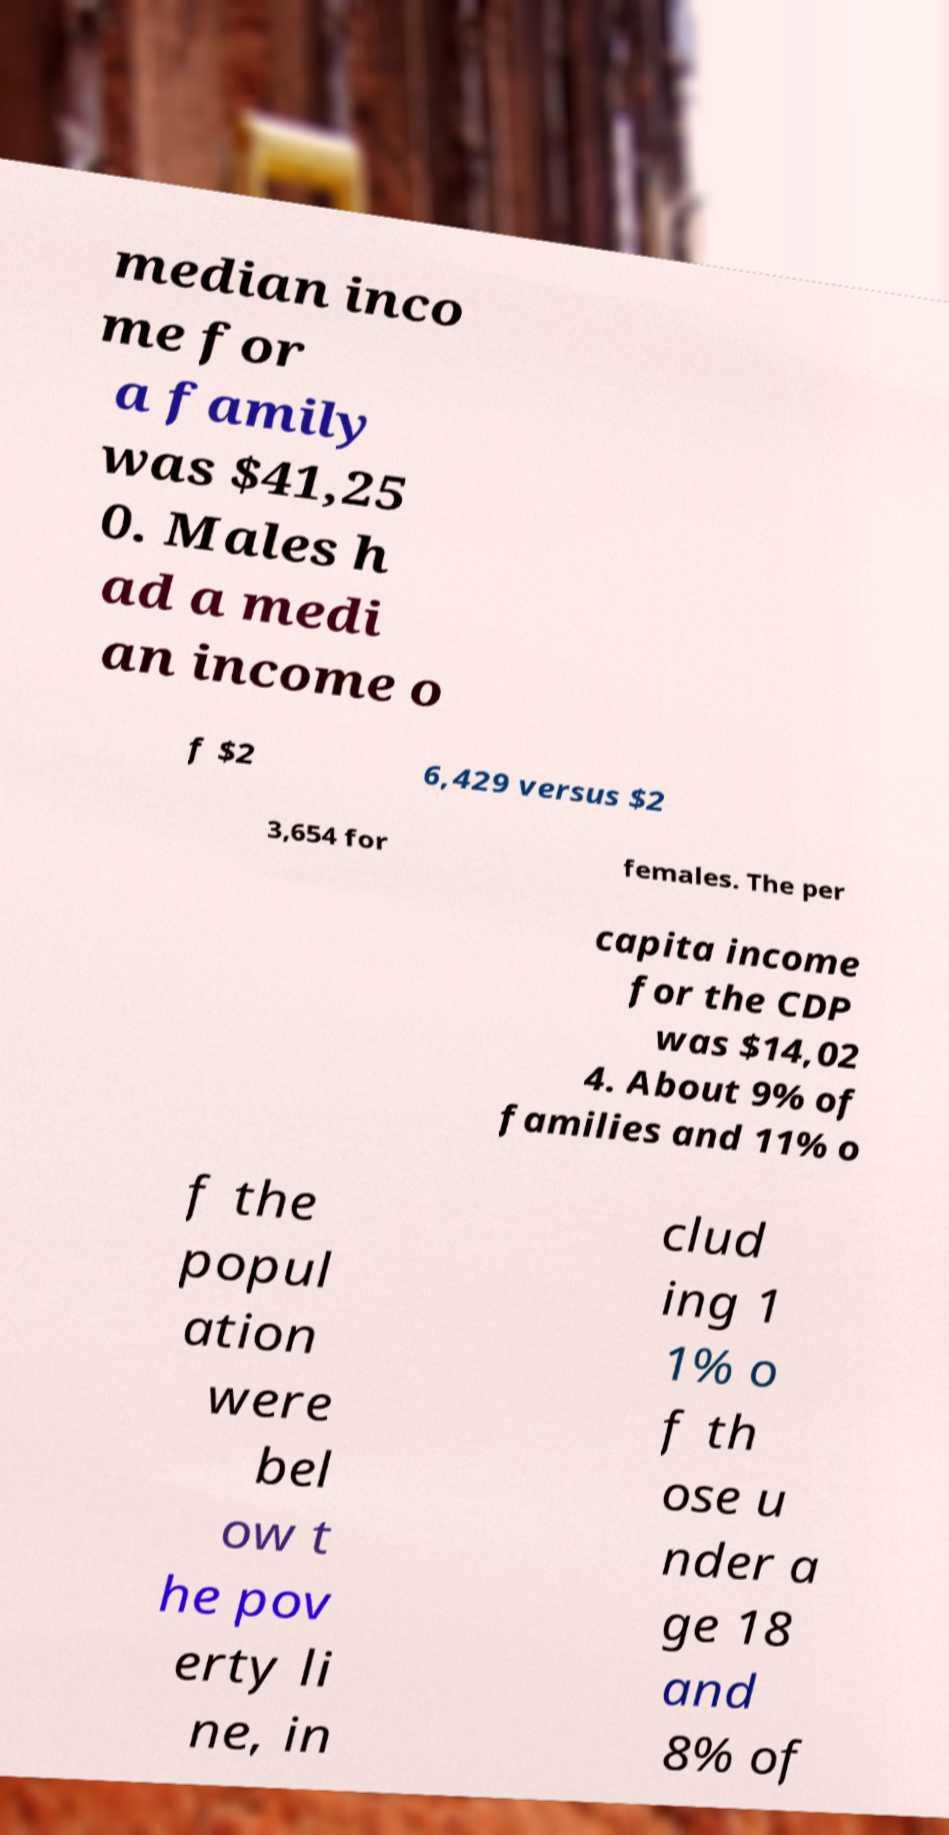I need the written content from this picture converted into text. Can you do that? median inco me for a family was $41,25 0. Males h ad a medi an income o f $2 6,429 versus $2 3,654 for females. The per capita income for the CDP was $14,02 4. About 9% of families and 11% o f the popul ation were bel ow t he pov erty li ne, in clud ing 1 1% o f th ose u nder a ge 18 and 8% of 